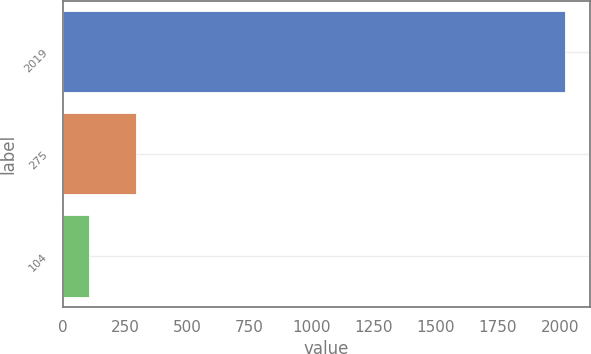<chart> <loc_0><loc_0><loc_500><loc_500><bar_chart><fcel>2019<fcel>275<fcel>104<nl><fcel>2018<fcel>295.4<fcel>104<nl></chart> 